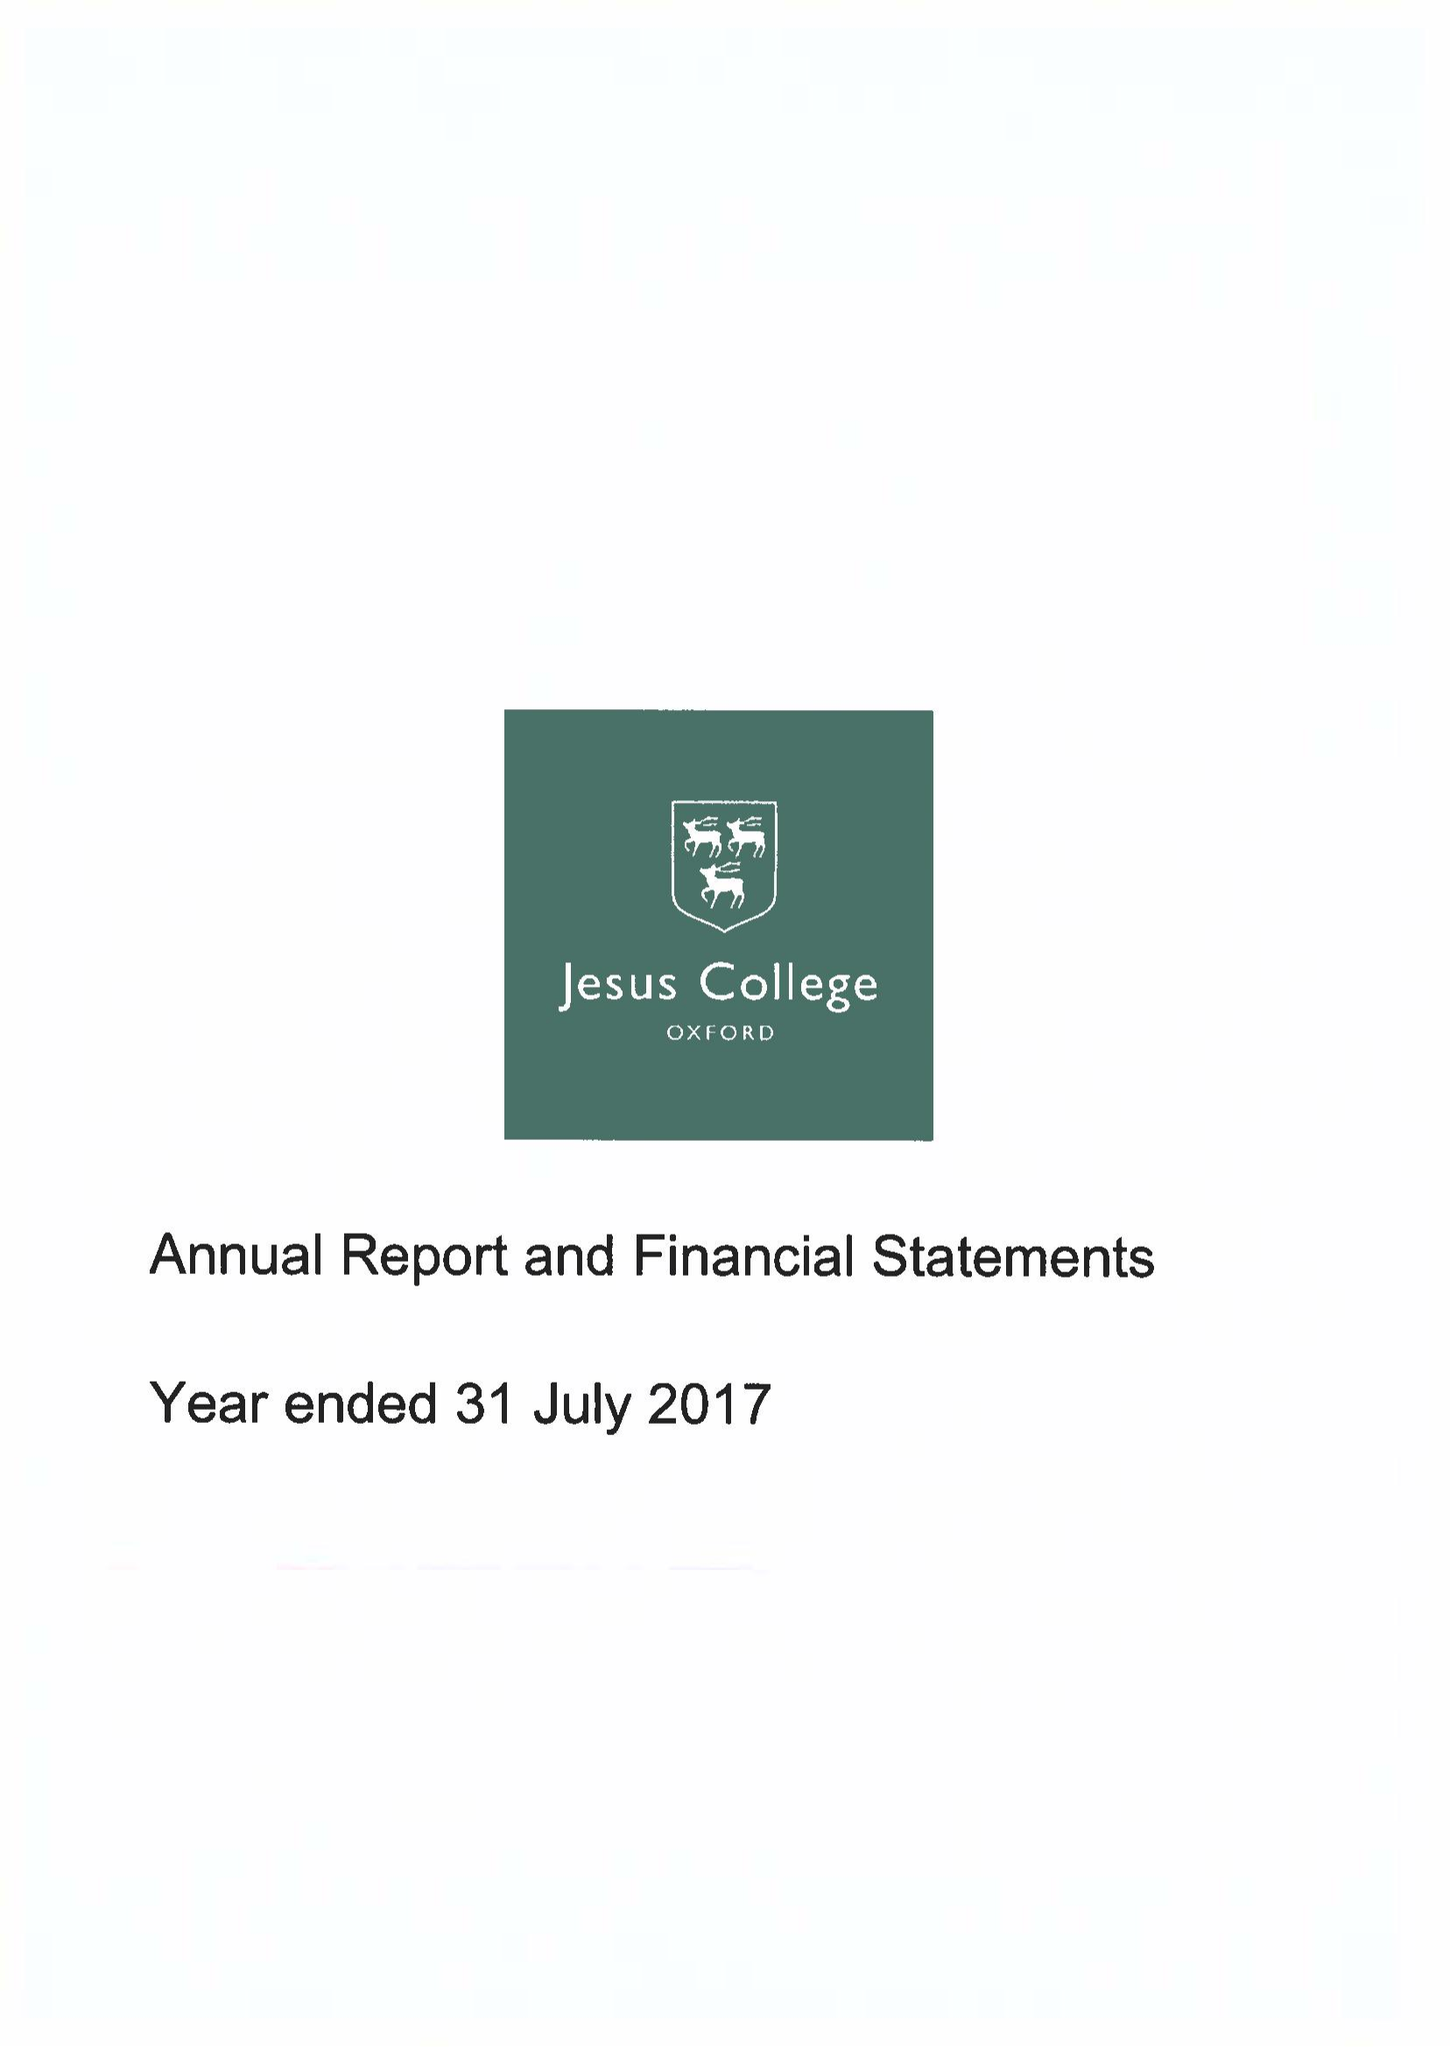What is the value for the income_annually_in_british_pounds?
Answer the question using a single word or phrase. 12923000.00 